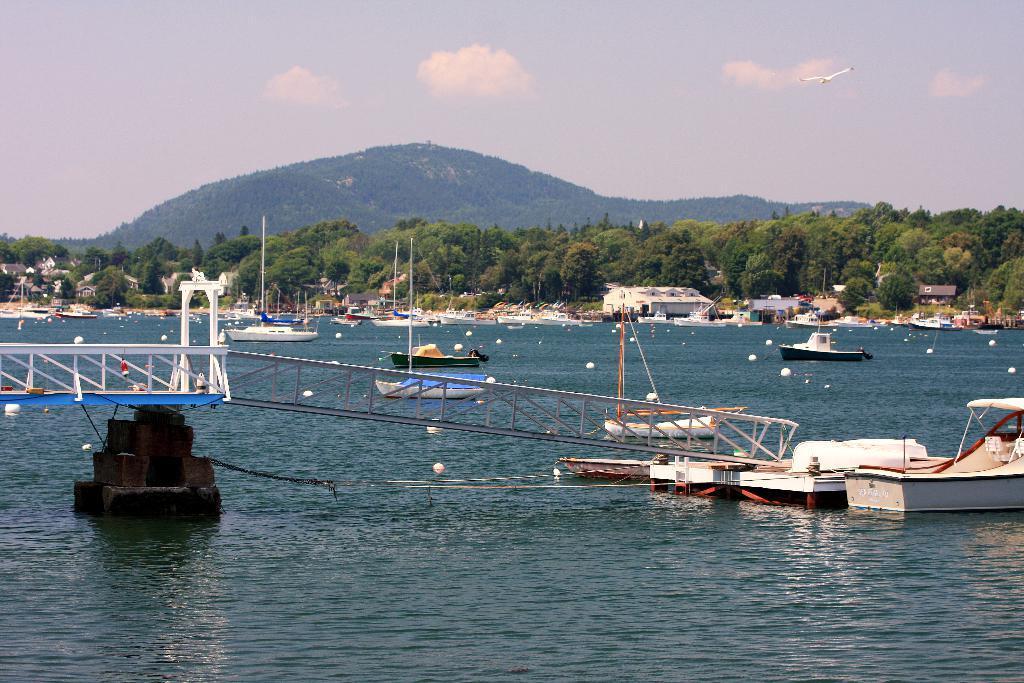How would you summarize this image in a sentence or two? In this image it seems like there is a river at the bottom. In the river there are so many boats. On the left side it looks like a bridge. There are some white color round balls in between the boats. In the middle there are so many trees. In the background there are hills. At the top there is the sky. There is a bird flying in the sky. There are few houses beside the trees. 